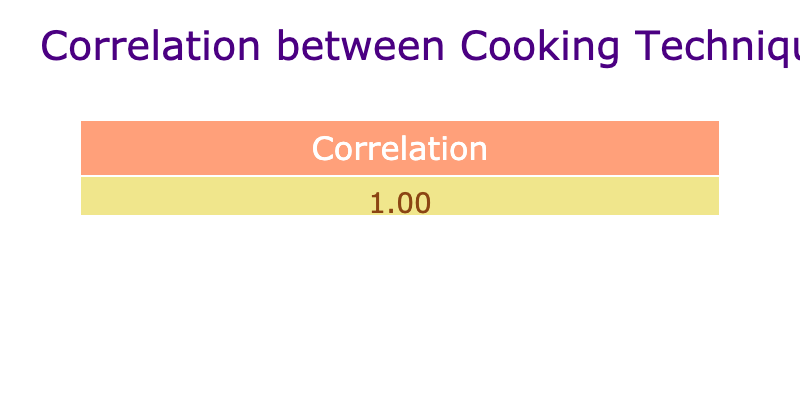What is the popularity score of Chocolate Lava Cake? The popularity score is directly provided in the table. The entry for Chocolate Lava Cake shows a Popularity_Score of 90.
Answer: 90 Which cooking technique corresponds to the highest popularity score? Looking through the table, Sous Vide has the highest popularity score of 95, which corresponds to Beef Steak.
Answer: Sous Vide Is the popularity score of Tandoori Chicken greater than 80? The table lists a popularity score of 92 for Tandoori Chicken, which is indeed greater than 80.
Answer: Yes What is the average popularity score for dishes that involve Frying, Steaming, and Sautéing? The popularity scores for these techniques are 78 (Frying), 82 (Steaming), and 88 (Sautéing). Adding these gives 78 + 82 + 88 = 248. There are 3 techniques, so the average is 248 / 3 = 82.67.
Answer: 82.67 Are there any dishes that were scored below 75? Checking the table, the lowest score is 70 for Green Bean Salad and 75 for Masala Cauliflower. Both are below the threshold of 75.
Answer: Yes Which cooking technique has the least popularity score? The least popularity score listed in the table is for Blanching with a score of 70.
Answer: Blanching If you were to rank the dishes by popularity from highest to lowest, which dish would come at number three? The ordered popularity scores from highest to lowest are: Beef Steak (95), Tandoori Chicken (92), Paneer Butter Masala (88) which is therefore ranked third.
Answer: Paneer Butter Masala What is the difference between the popularity scores of Sous Vide and Roasting? Sous Vide has a score of 95 and Roasting has a score of 75. The difference is 95 - 75 = 20.
Answer: 20 Which cooking technique has an associated popularity score of 75 or above? By reviewing the table, all techniques except for Blanching (70) and Masala Cauliflower (75) have scores of 75 or above; thus, multiple techniques meet this criterion.
Answer: Multiple techniques 